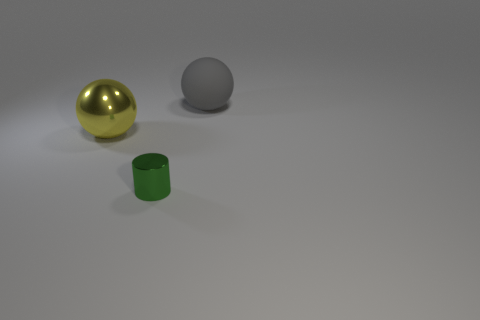Is there any other thing that is made of the same material as the gray ball?
Give a very brief answer. No. There is a large object right of the small green cylinder; what color is it?
Provide a succinct answer. Gray. Is the material of the yellow ball the same as the small object?
Make the answer very short. Yes. What number of objects are gray objects or balls that are on the left side of the large gray rubber object?
Offer a very short reply. 2. There is a large object to the left of the big gray matte sphere; what is its shape?
Provide a succinct answer. Sphere. There is a sphere left of the matte thing; is its size the same as the gray matte thing?
Your answer should be compact. Yes. Is there a gray matte object behind the metallic thing behind the green shiny thing?
Offer a terse response. Yes. Are there any small green objects that have the same material as the yellow sphere?
Your answer should be very brief. Yes. There is a object that is on the right side of the thing in front of the yellow thing; what is it made of?
Provide a short and direct response. Rubber. What is the material of the thing that is both left of the gray sphere and behind the tiny metal object?
Keep it short and to the point. Metal. 